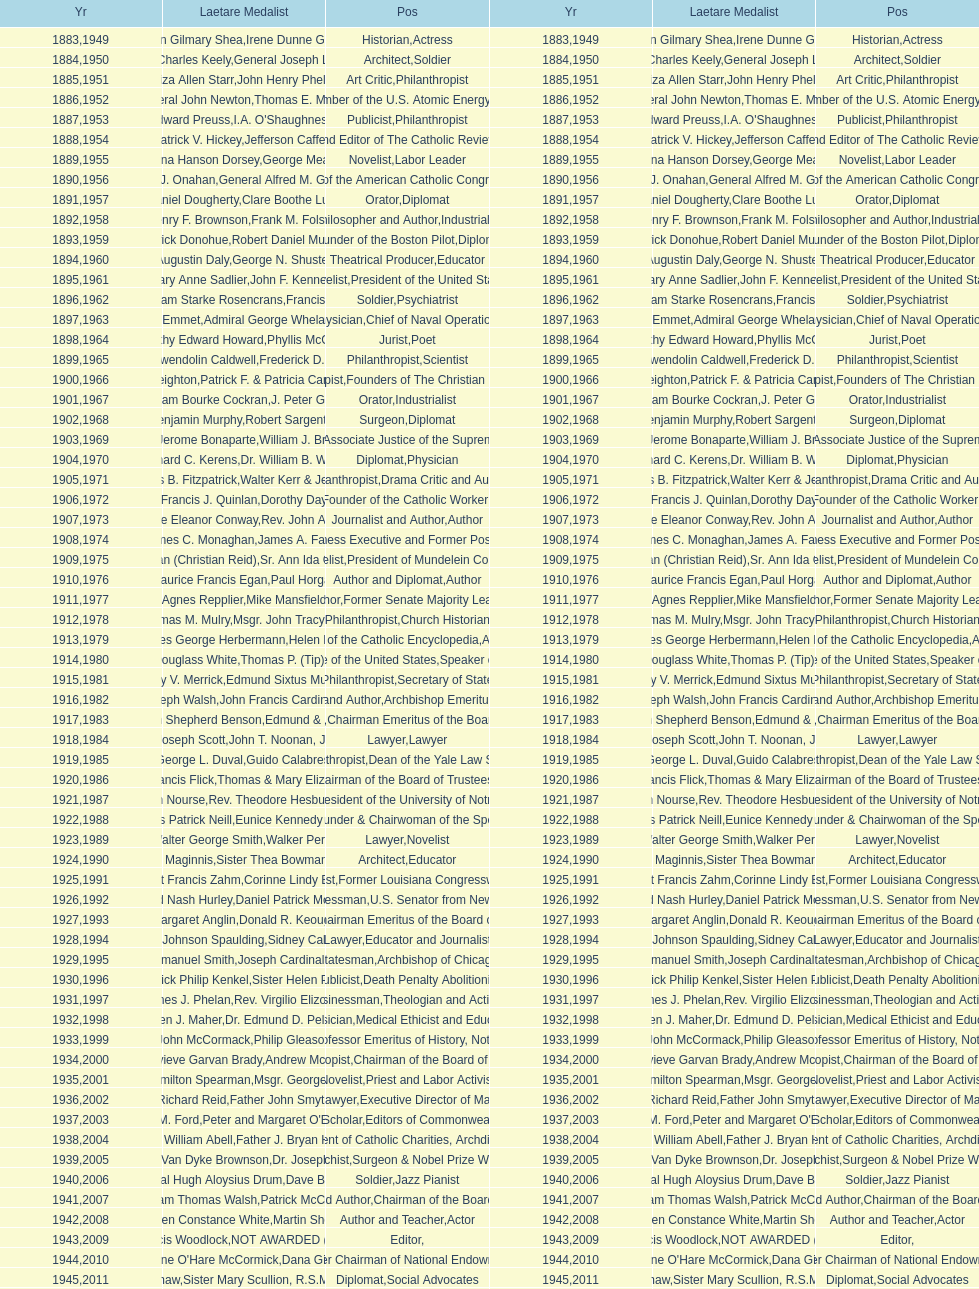How many are or were journalists? 5. 